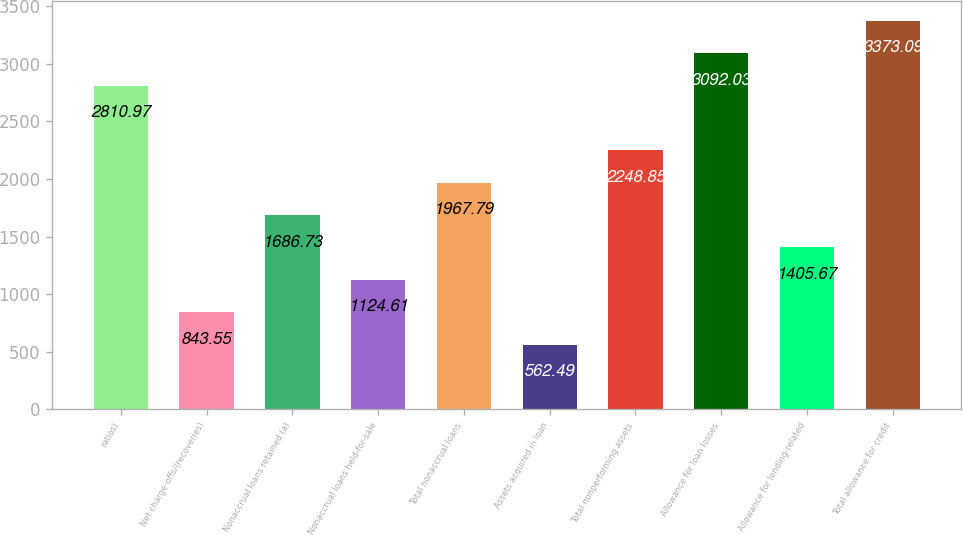Convert chart. <chart><loc_0><loc_0><loc_500><loc_500><bar_chart><fcel>ratios)<fcel>Net charge-offs/(recoveries)<fcel>Nonaccrual loans retained (a)<fcel>Nonaccrual loans held-for-sale<fcel>Total nonaccrual loans<fcel>Assets acquired in loan<fcel>Total nonperforming assets<fcel>Allowance for loan losses<fcel>Allowance for lending-related<fcel>Total allowance for credit<nl><fcel>2810.97<fcel>843.55<fcel>1686.73<fcel>1124.61<fcel>1967.79<fcel>562.49<fcel>2248.85<fcel>3092.03<fcel>1405.67<fcel>3373.09<nl></chart> 